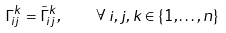Convert formula to latex. <formula><loc_0><loc_0><loc_500><loc_500>\Gamma _ { i j } ^ { k } = \tilde { \Gamma } _ { i j } ^ { k } , \quad \forall \, i , j , k \in \{ 1 , \dots , n \}</formula> 